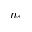Convert formula to latex. <formula><loc_0><loc_0><loc_500><loc_500>n _ { \uparrow }</formula> 